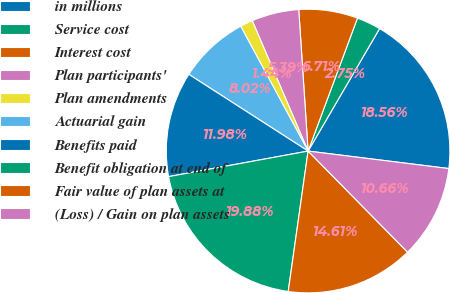Convert chart. <chart><loc_0><loc_0><loc_500><loc_500><pie_chart><fcel>in millions<fcel>Service cost<fcel>Interest cost<fcel>Plan participants'<fcel>Plan amendments<fcel>Actuarial gain<fcel>Benefits paid<fcel>Benefit obligation at end of<fcel>Fair value of plan assets at<fcel>(Loss) / Gain on plan assets<nl><fcel>18.56%<fcel>2.75%<fcel>6.71%<fcel>5.39%<fcel>1.44%<fcel>8.02%<fcel>11.98%<fcel>19.88%<fcel>14.61%<fcel>10.66%<nl></chart> 